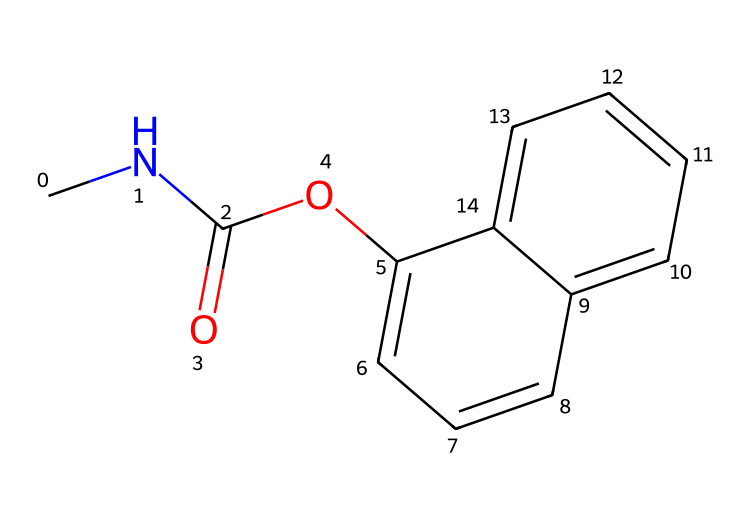What is the molecular formula of carbaryl? To determine the molecular formula, we need to count the atoms of each element in the chemical structure. In the SMILES representation, we identify: 9 carbon (C) atoms, 10 hydrogen (H) atoms, 1 nitrogen (N) atom, and 1 oxygen (O) atom. Therefore, the molecular formula is C12H15N1O2.
Answer: C12H15NO2 How many rings are present in the structure of carbaryl? By examining the SMILES structure, we can identify two fused benzene rings, which indicates that there are 2 rings total present in the structure.
Answer: 2 What type of functional group is present in carbaryl? The presence of the carbonyl (C=O) and the ether (C-O-C) functionalities can be recognized in the structure. In this case, the amide functional group is indicated by the carbonyl directly attached to a nitrogen atom.
Answer: amide What element contributes to the toxicity of pesticides like carbaryl? The nitrogen atom found in the structure is often associated with the toxicity of pesticides, especially in compounds that inhibit acetylcholinesterase. This mechanism contributes to the effectiveness of carbaryl as a pesticide.
Answer: nitrogen How many double bonds are in the structure of carbaryl? The representation shows 2 carbon-nitrogen double bonds present in the carbonyl and aromatic parts of the compound. Hence, there are 2 double bonds overall.
Answer: 2 What is the characteristic feature of the carbaryl's structure that contributes to its insecticidal properties? The presence of the carbamate group (which includes the nitrogen atom) is notable for its mechanism of action in disrupting the normal functioning of pests. This makes it characteristic for insecticidal efficacy.
Answer: carbamate group 